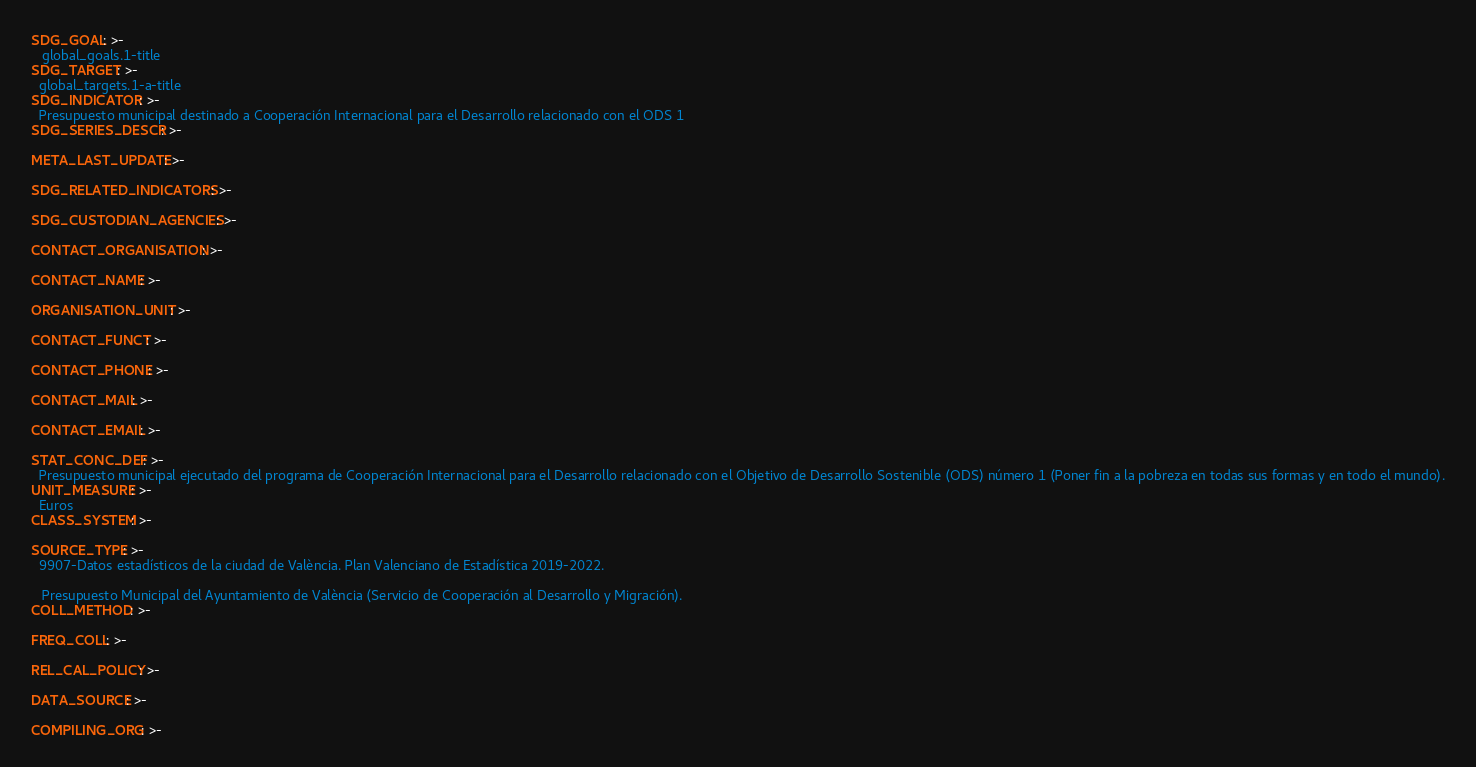<code> <loc_0><loc_0><loc_500><loc_500><_YAML_>SDG_GOAL: >-
   global_goals.1-title
SDG_TARGET: >-
  global_targets.1-a-title
SDG_INDICATOR: >-
  Presupuesto municipal destinado a Cooperación Internacional para el Desarrollo relacionado con el ODS 1
SDG_SERIES_DESCR: >-

META_LAST_UPDATE: >-

SDG_RELATED_INDICATORS: >-

SDG_CUSTODIAN_AGENCIES: >-

CONTACT_ORGANISATION: >-

CONTACT_NAME: >-

ORGANISATION_UNIT: >-

CONTACT_FUNCT: >-

CONTACT_PHONE: >-

CONTACT_MAIL: >-

CONTACT_EMAIL: >-

STAT_CONC_DEF: >- 
  Presupuesto municipal ejecutado del programa de Cooperación Internacional para el Desarrollo relacionado con el Objetivo de Desarrollo Sostenible (ODS) número 1 (Poner fin a la pobreza en todas sus formas y en todo el mundo).
UNIT_MEASURE: >-
  Euros
CLASS_SYSTEM: >-

SOURCE_TYPE: >-
  9907-Datos estadísticos de la ciudad de València. Plan Valenciano de Estadística 2019-2022.
   
   Presupuesto Municipal del Ayuntamiento de València (Servicio de Cooperación al Desarrollo y Migración).
COLL_METHOD: >-

FREQ_COLL: >-

REL_CAL_POLICY: >-

DATA_SOURCE: >-

COMPILING_ORG: >-</code> 